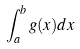Convert formula to latex. <formula><loc_0><loc_0><loc_500><loc_500>\int _ { a } ^ { b } g ( x ) d x</formula> 